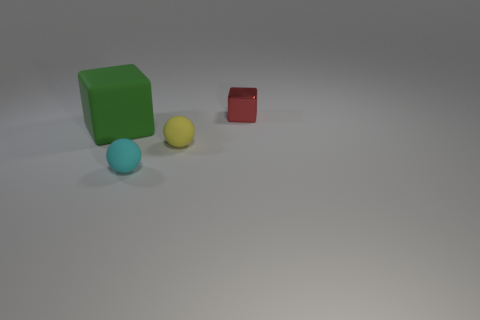What number of blue things are tiny matte things or shiny cubes?
Make the answer very short. 0. Is there anything else that is the same material as the small red cube?
Keep it short and to the point. No. What material is the other thing that is the same shape as the big green thing?
Provide a succinct answer. Metal. Is the number of green cubes that are on the right side of the big green cube the same as the number of tiny cubes?
Your answer should be compact. No. There is a matte object that is both behind the cyan rubber ball and right of the green block; how big is it?
Provide a succinct answer. Small. There is a sphere that is right of the tiny rubber sphere that is in front of the small yellow thing; how big is it?
Give a very brief answer. Small. There is a object that is both behind the small yellow matte sphere and on the right side of the green rubber block; what is its color?
Your response must be concise. Red. What number of other things are the same size as the green rubber object?
Keep it short and to the point. 0. There is a cyan matte sphere; does it have the same size as the thing that is behind the green cube?
Provide a short and direct response. Yes. The other matte object that is the same size as the yellow thing is what color?
Provide a succinct answer. Cyan. 